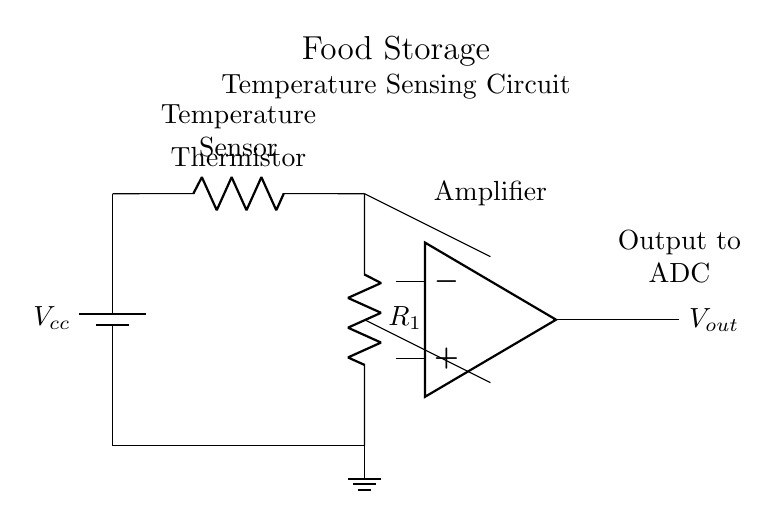What type of sensor is used in this circuit? The diagram indicates a thermistor is used, which is a type of sensor that changes resistance with temperature.
Answer: Thermistor What component provides the output voltage? The output voltage is provided by the operational amplifier, which amplifies the signal from the thermistor and resistor combination.
Answer: Operational amplifier How many resistors are present in the circuit? There are two resistors in the circuit: one is a thermistor and the other is a fixed resistor denoted as R1.
Answer: Two What is the function of the operational amplifier? The operational amplifier receives inputs from the resistors and amplifies the voltage signal, making it suitable for further processing, such as converting to a digital signal.
Answer: Amplification What is the purpose of the ground connection in this circuit? The ground connection serves as a reference point for the voltages in the circuit, ensuring stability in operation and preventing floating potentials.
Answer: Reference point What is the output of the circuit directed towards? The output of the circuit is directed towards an Analog-to-Digital Converter (ADC), which transforms the amplified analog voltage into a digital signal for monitoring.
Answer: ADC 